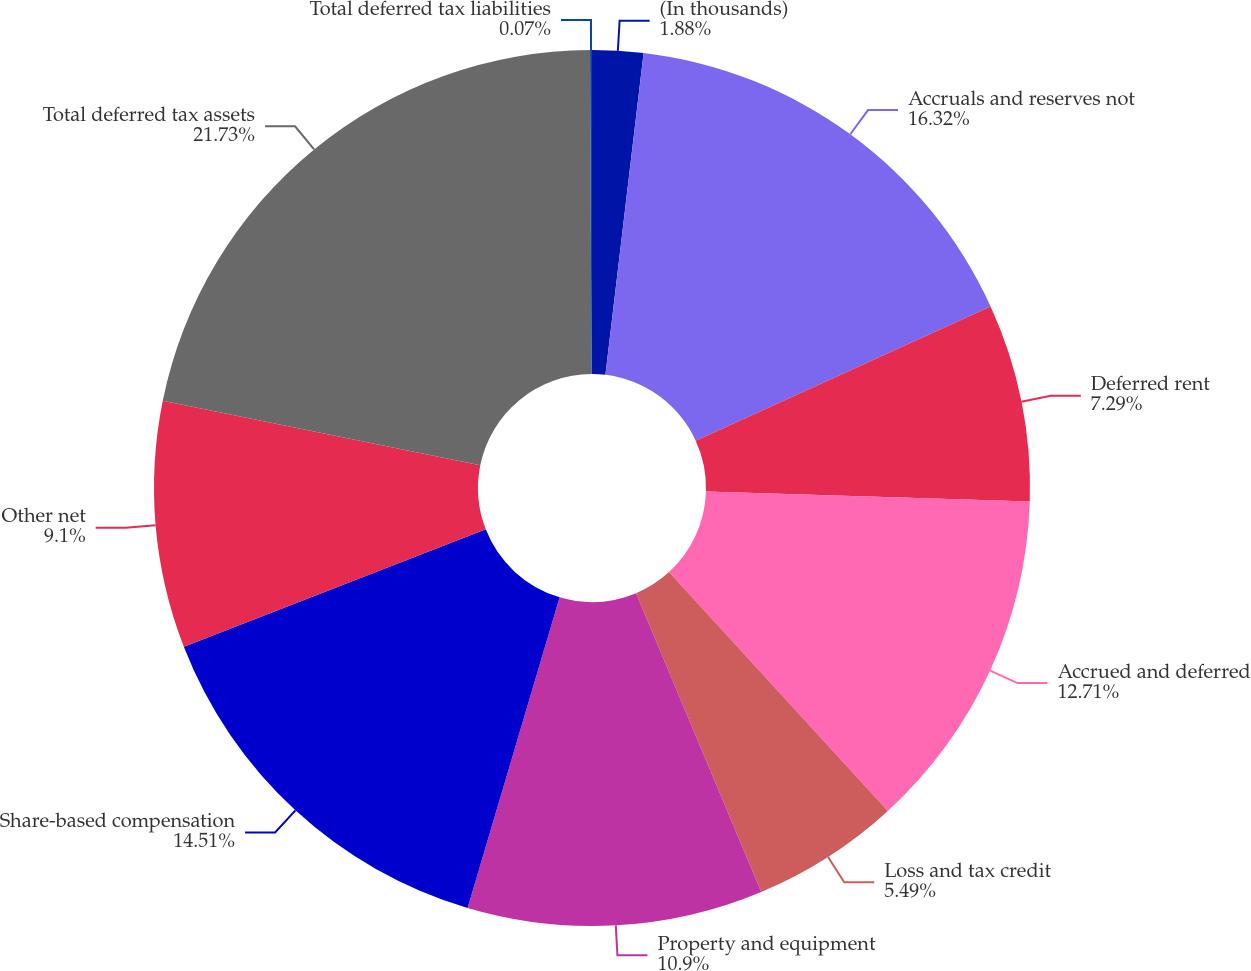<chart> <loc_0><loc_0><loc_500><loc_500><pie_chart><fcel>(In thousands)<fcel>Accruals and reserves not<fcel>Deferred rent<fcel>Accrued and deferred<fcel>Loss and tax credit<fcel>Property and equipment<fcel>Share-based compensation<fcel>Other net<fcel>Total deferred tax assets<fcel>Total deferred tax liabilities<nl><fcel>1.88%<fcel>16.32%<fcel>7.29%<fcel>12.71%<fcel>5.49%<fcel>10.9%<fcel>14.51%<fcel>9.1%<fcel>21.74%<fcel>0.07%<nl></chart> 